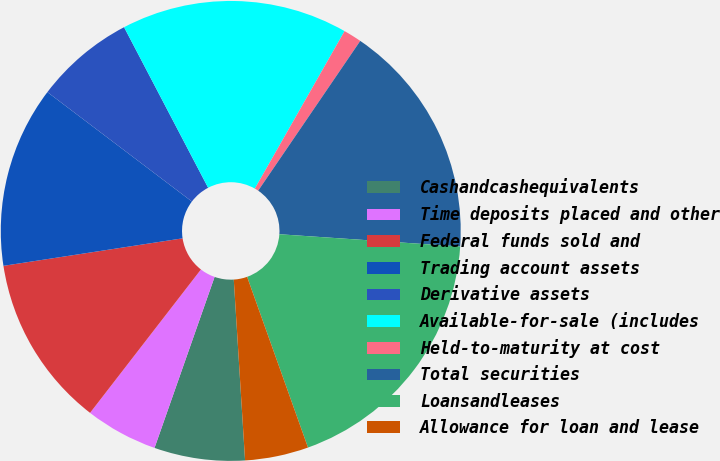<chart> <loc_0><loc_0><loc_500><loc_500><pie_chart><fcel>Cashandcashequivalents<fcel>Time deposits placed and other<fcel>Federal funds sold and<fcel>Trading account assets<fcel>Derivative assets<fcel>Available-for-sale (includes<fcel>Held-to-maturity at cost<fcel>Total securities<fcel>Loansandleases<fcel>Allowance for loan and lease<nl><fcel>6.37%<fcel>5.1%<fcel>12.1%<fcel>12.74%<fcel>7.01%<fcel>15.92%<fcel>1.28%<fcel>16.56%<fcel>18.47%<fcel>4.46%<nl></chart> 